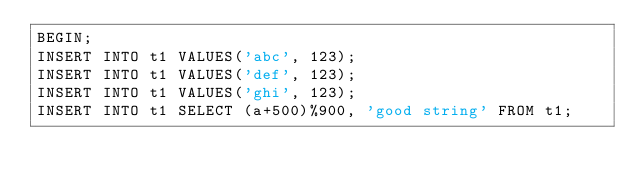Convert code to text. <code><loc_0><loc_0><loc_500><loc_500><_SQL_>BEGIN;
INSERT INTO t1 VALUES('abc', 123);
INSERT INTO t1 VALUES('def', 123);
INSERT INTO t1 VALUES('ghi', 123);
INSERT INTO t1 SELECT (a+500)%900, 'good string' FROM t1;</code> 